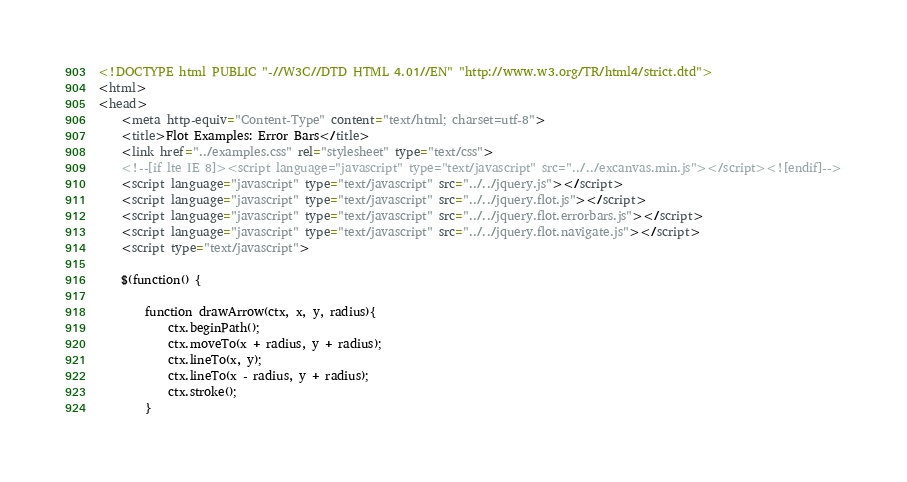Convert code to text. <code><loc_0><loc_0><loc_500><loc_500><_HTML_><!DOCTYPE html PUBLIC "-//W3C//DTD HTML 4.01//EN" "http://www.w3.org/TR/html4/strict.dtd">
<html>
<head>
	<meta http-equiv="Content-Type" content="text/html; charset=utf-8">
	<title>Flot Examples: Error Bars</title>
	<link href="../examples.css" rel="stylesheet" type="text/css">
	<!--[if lte IE 8]><script language="javascript" type="text/javascript" src="../../excanvas.min.js"></script><![endif]-->
	<script language="javascript" type="text/javascript" src="../../jquery.js"></script>
	<script language="javascript" type="text/javascript" src="../../jquery.flot.js"></script>
	<script language="javascript" type="text/javascript" src="../../jquery.flot.errorbars.js"></script>
	<script language="javascript" type="text/javascript" src="../../jquery.flot.navigate.js"></script>
	<script type="text/javascript">

	$(function() {

		function drawArrow(ctx, x, y, radius){
			ctx.beginPath();
			ctx.moveTo(x + radius, y + radius);
			ctx.lineTo(x, y);
			ctx.lineTo(x - radius, y + radius);
			ctx.stroke();
		}
</code> 